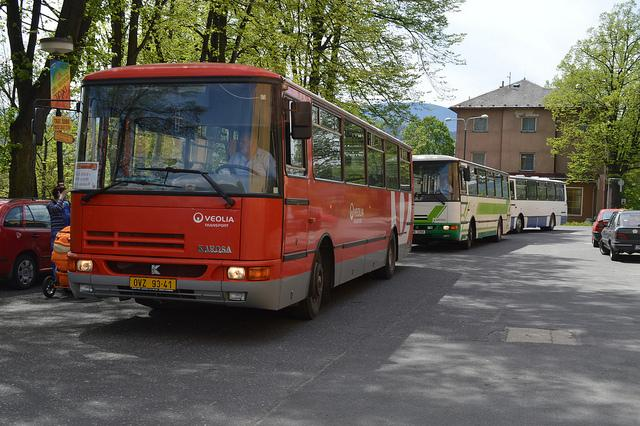Why are the buses lined up? Please explain your reasoning. awaiting passengers. Based on the background and the fact that these buses are lined up like this, they are probably parked near a tourist destination of some kind. there are no visible passengers on the buses, so if they are present, the buses are likely waiting for them to return to the bus. 